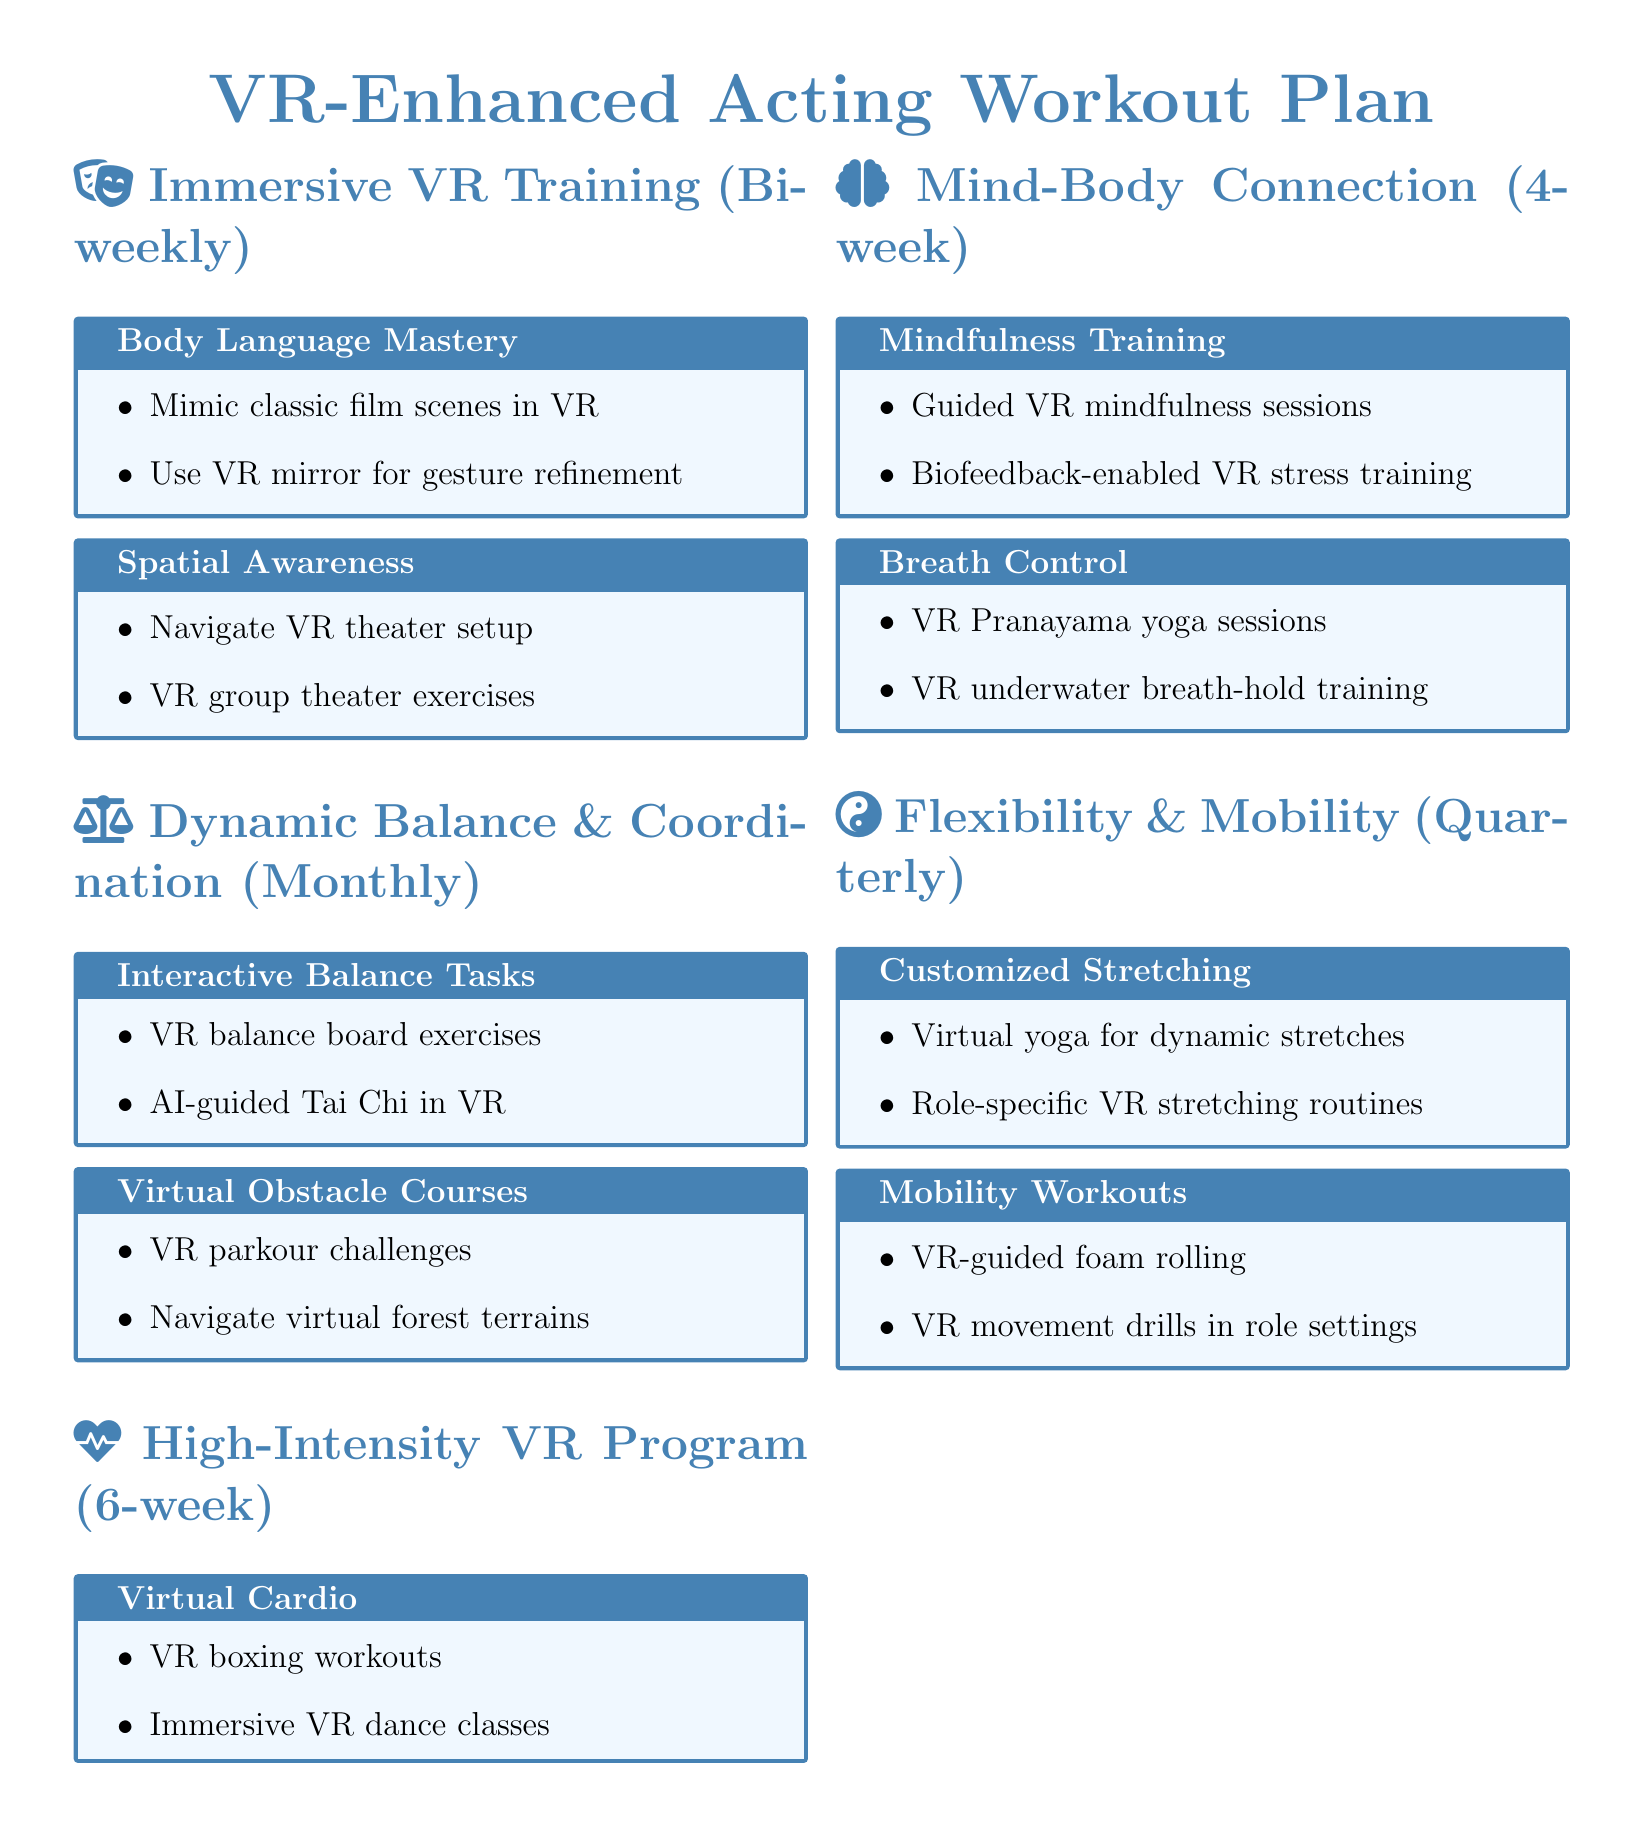What is the title of the document? The title of the document is clearly stated at the beginning as "VR-Enhanced Acting Workout Plan".
Answer: VR-Enhanced Acting Workout Plan How often are the Immersive VR Training workouts scheduled? The document specifies that the Immersive VR Training workouts are conducted bi-weekly.
Answer: Bi-weekly What type of exercises are included in the Dynamic Balance and Coordination routine? The routine includes interactive balance tasks and virtual obstacle courses.
Answer: Interactive balance tasks and virtual obstacle courses How many weeks is the High-Intensity VR Cardio and Strength Program? The program is noted to last for six weeks.
Answer: Six weeks What does the Mind-Body Connection workout focus on? The workout focuses on mindfulness, breath control, and virtual reality meditation sessions.
Answer: Mindfulness, breath control, and virtual reality meditation sessions What is one of the features of the Customized Stretching in the Flexibility and Mobility regimen? The Customized Stretching includes role-specific VR stretching routines.
Answer: Role-specific VR stretching routines How many distinct workout plans are mentioned in the document? The document contains five distinct workout plans, each with unique focuses.
Answer: Five What type of yoga sessions are included in the Mind-Body Connection workouts? The Mind-Body Connection workouts include VR Pranayama yoga sessions.
Answer: VR Pranayama yoga sessions What is one type of exercise included in the Virtual Cardio section? The Virtual Cardio section includes immersive VR dance classes.
Answer: Immersive VR dance classes 